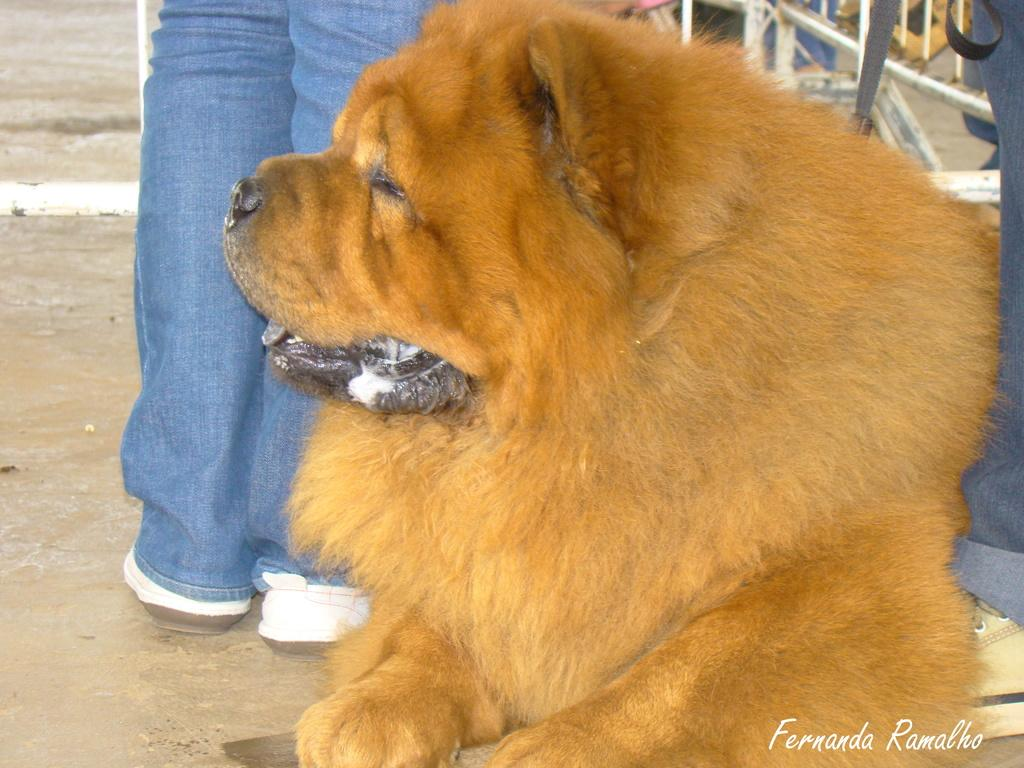What is the main subject in the center of the image? There is a dog in the center of the image. What can be seen in the background of the image? There are people and a metal object in the background of the image. Is there any text present in the image? Yes, there is text at the bottom side of the image. How many legs does the house have in the image? There is no house present in the image, so it is not possible to determine the number of legs it might have. 